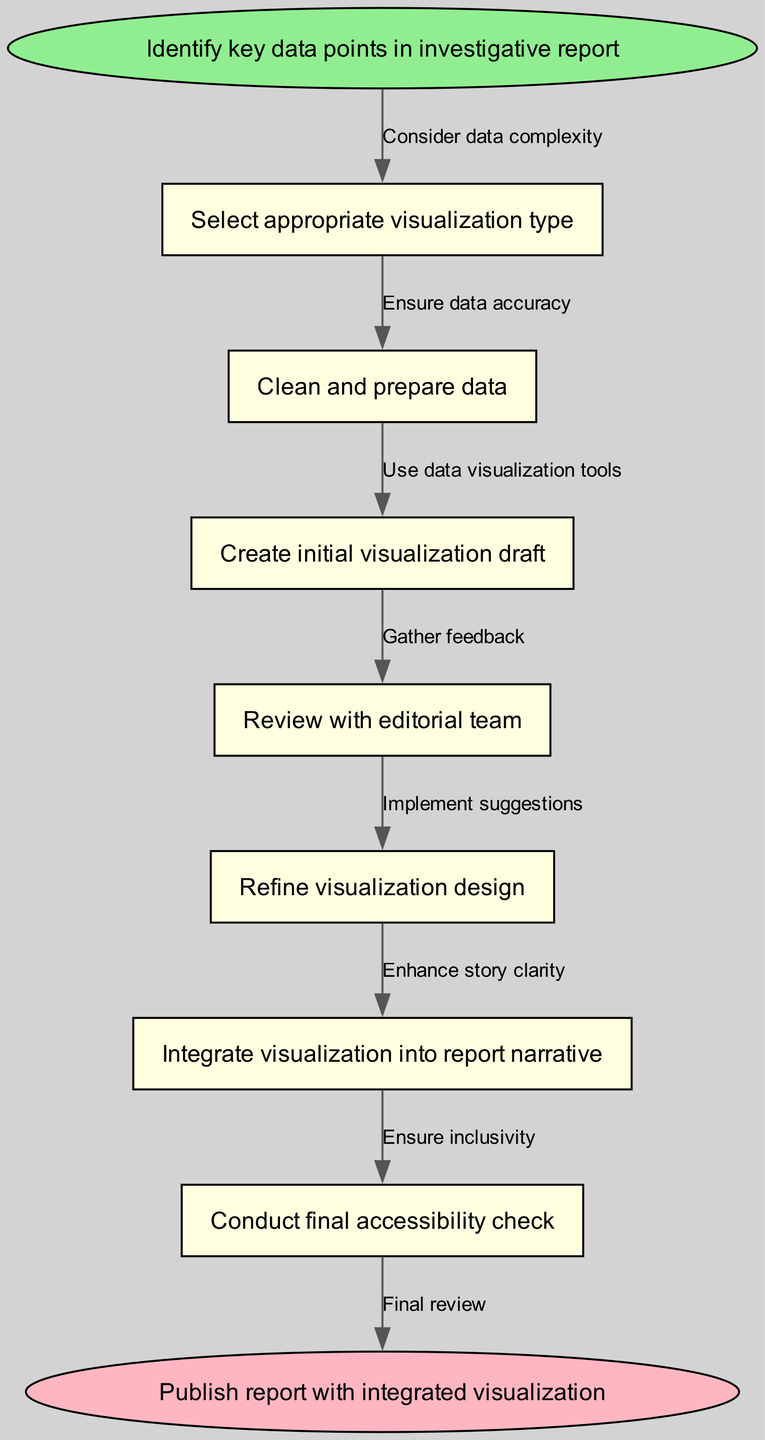What is the starting point of the flow chart? The starting point is labeled as "Identify key data points in investigative report." This is explicitly stated at the top of the flow chart as the initial node from which the process begins.
Answer: Identify key data points in investigative report How many nodes are there in total? By counting each individual point within the flow chart, there are a total of 8 nodes: one start node, six process nodes, and one end node.
Answer: 8 What comes immediately after selecting appropriate visualization type? The node that follows "Select appropriate visualization type" is "Clean and prepare data." This is indicated by a direct edge from node 1 to node 2 in the flow chart.
Answer: Clean and prepare data What is the purpose of the node labeled "Review with editorial team"? The purpose of this node is to "Gather feedback." It is a key step where input from the editorial team is sought to ensure the visualization aligns with the report's goals.
Answer: Gather feedback What is the last node before the report is published? The last node before the report is published is "Conduct final accessibility check." This is the final quality assurance step before the report is completed and shared.
Answer: Conduct final accessibility check What action follows refining visualization design? The action that follows refining visualization design is "Integrate visualization into report narrative." This connects the visualization directly to the text of the report.
Answer: Integrate visualization into report narrative How does the flow from initial visualization draft to editorial team review impact the final output? The flow from "Create initial visualization draft" to "Review with editorial team" allows for feedback to be received and adjustments made, improving the overall quality and clarity of the final output. This interaction enhances the effectiveness of the visualization in conveying the report's message.
Answer: Improves clarity and quality What ensures inclusivity in the process? The node "Conduct final accessibility check" ensures inclusivity, focusing on making the visualization comprehensible and accessible to all audiences.
Answer: Conduct final accessibility check 